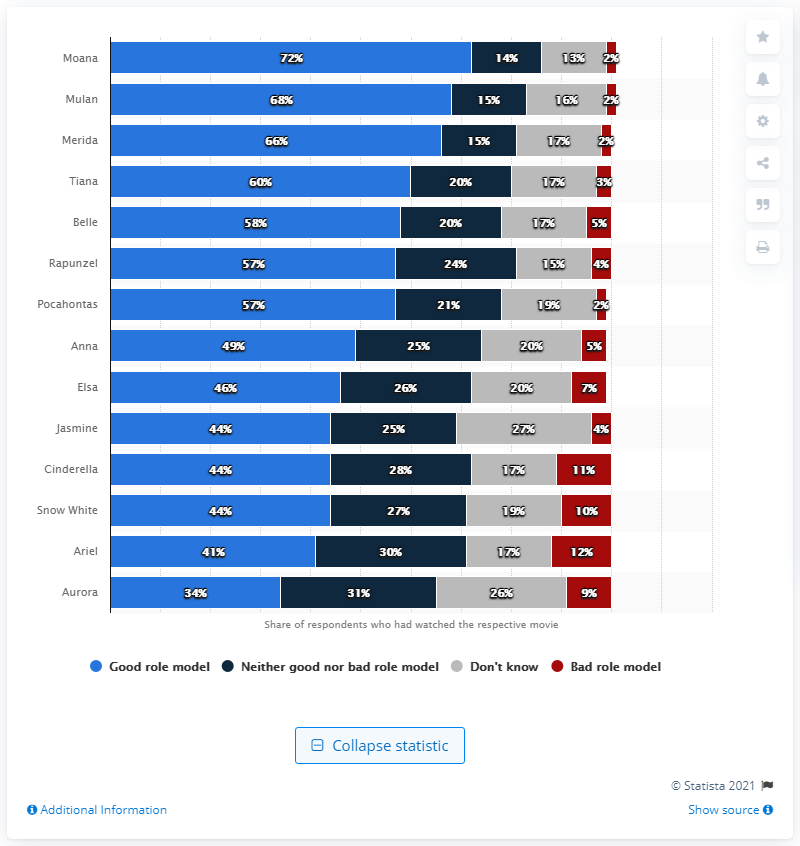Identify some key points in this picture. According to a study, 68% of British adults believed that Mulan and Merida were good role models. 